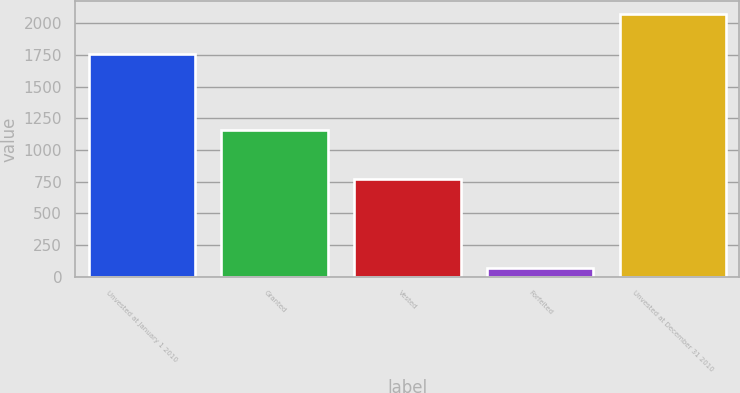Convert chart to OTSL. <chart><loc_0><loc_0><loc_500><loc_500><bar_chart><fcel>Unvested at January 1 2010<fcel>Granted<fcel>Vested<fcel>Forfeited<fcel>Unvested at December 31 2010<nl><fcel>1756<fcel>1154<fcel>774<fcel>66<fcel>2070<nl></chart> 